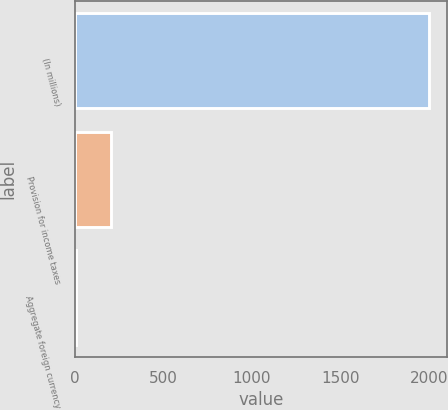Convert chart to OTSL. <chart><loc_0><loc_0><loc_500><loc_500><bar_chart><fcel>(In millions)<fcel>Provision for income taxes<fcel>Aggregate foreign currency<nl><fcel>2003<fcel>202.1<fcel>2<nl></chart> 